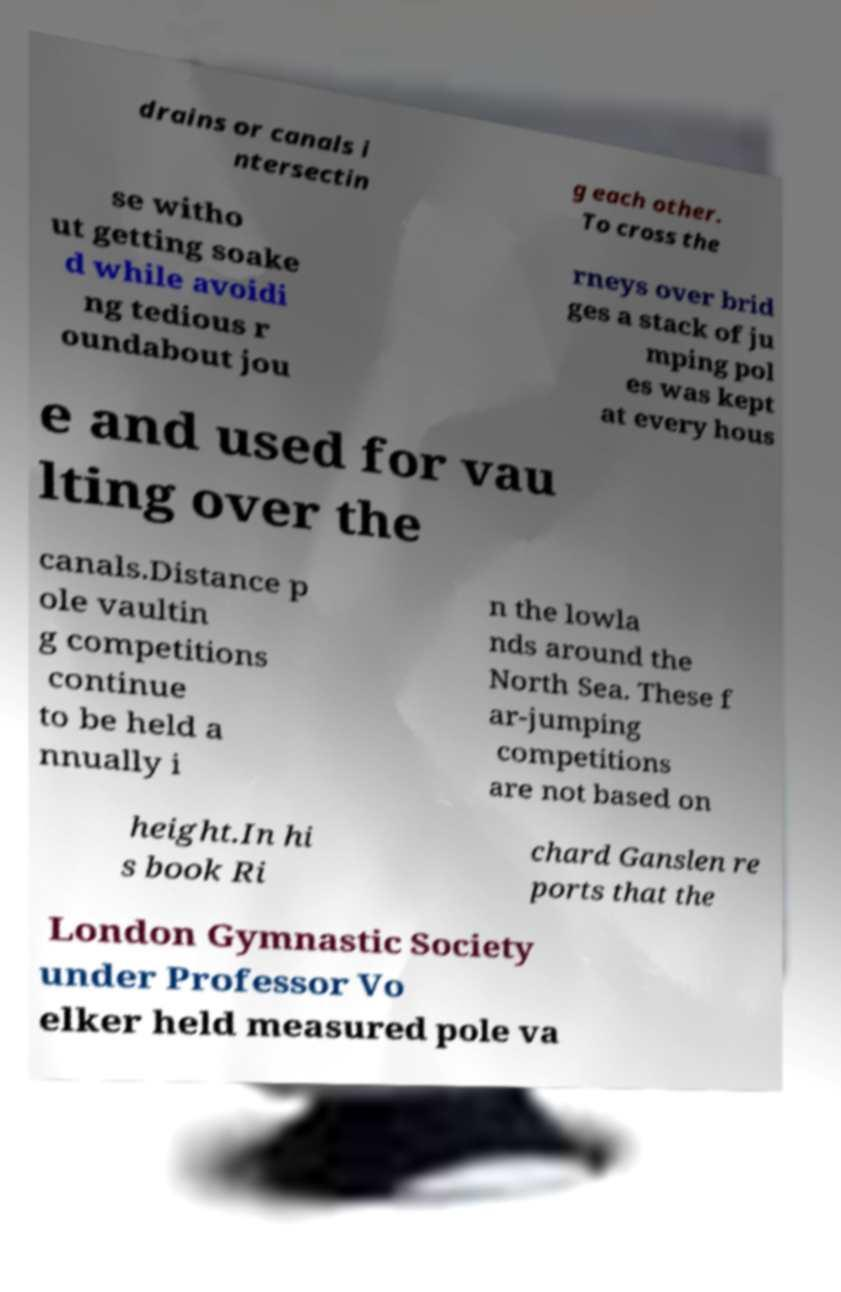There's text embedded in this image that I need extracted. Can you transcribe it verbatim? drains or canals i ntersectin g each other. To cross the se witho ut getting soake d while avoidi ng tedious r oundabout jou rneys over brid ges a stack of ju mping pol es was kept at every hous e and used for vau lting over the canals.Distance p ole vaultin g competitions continue to be held a nnually i n the lowla nds around the North Sea. These f ar-jumping competitions are not based on height.In hi s book Ri chard Ganslen re ports that the London Gymnastic Society under Professor Vo elker held measured pole va 